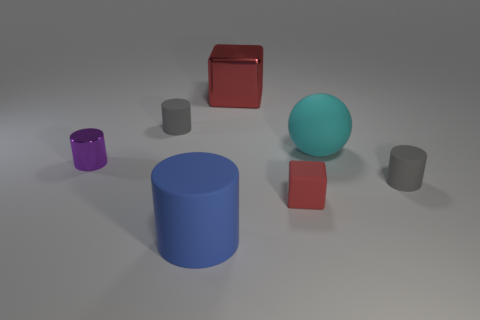How big is the matte cylinder that is in front of the gray thing on the right side of the red metal object?
Your answer should be compact. Large. Is the number of large red things that are on the right side of the red rubber block the same as the number of big spheres that are in front of the blue rubber cylinder?
Provide a short and direct response. Yes. There is a big metallic block behind the cyan matte sphere; are there any gray matte cylinders right of it?
Provide a succinct answer. Yes. There is a tiny cylinder that is on the left side of the small gray cylinder that is left of the big metallic object; what number of cyan rubber balls are left of it?
Offer a very short reply. 0. Are there fewer small rubber cylinders than cyan objects?
Provide a succinct answer. No. There is a gray rubber object that is left of the rubber cube; is it the same shape as the red thing that is behind the tiny red cube?
Offer a very short reply. No. What is the color of the small metallic object?
Ensure brevity in your answer.  Purple. What number of shiny things are cylinders or big cubes?
Offer a terse response. 2. There is a metallic object that is the same shape as the blue rubber object; what is its color?
Make the answer very short. Purple. Are any tiny purple matte cubes visible?
Your answer should be very brief. No. 